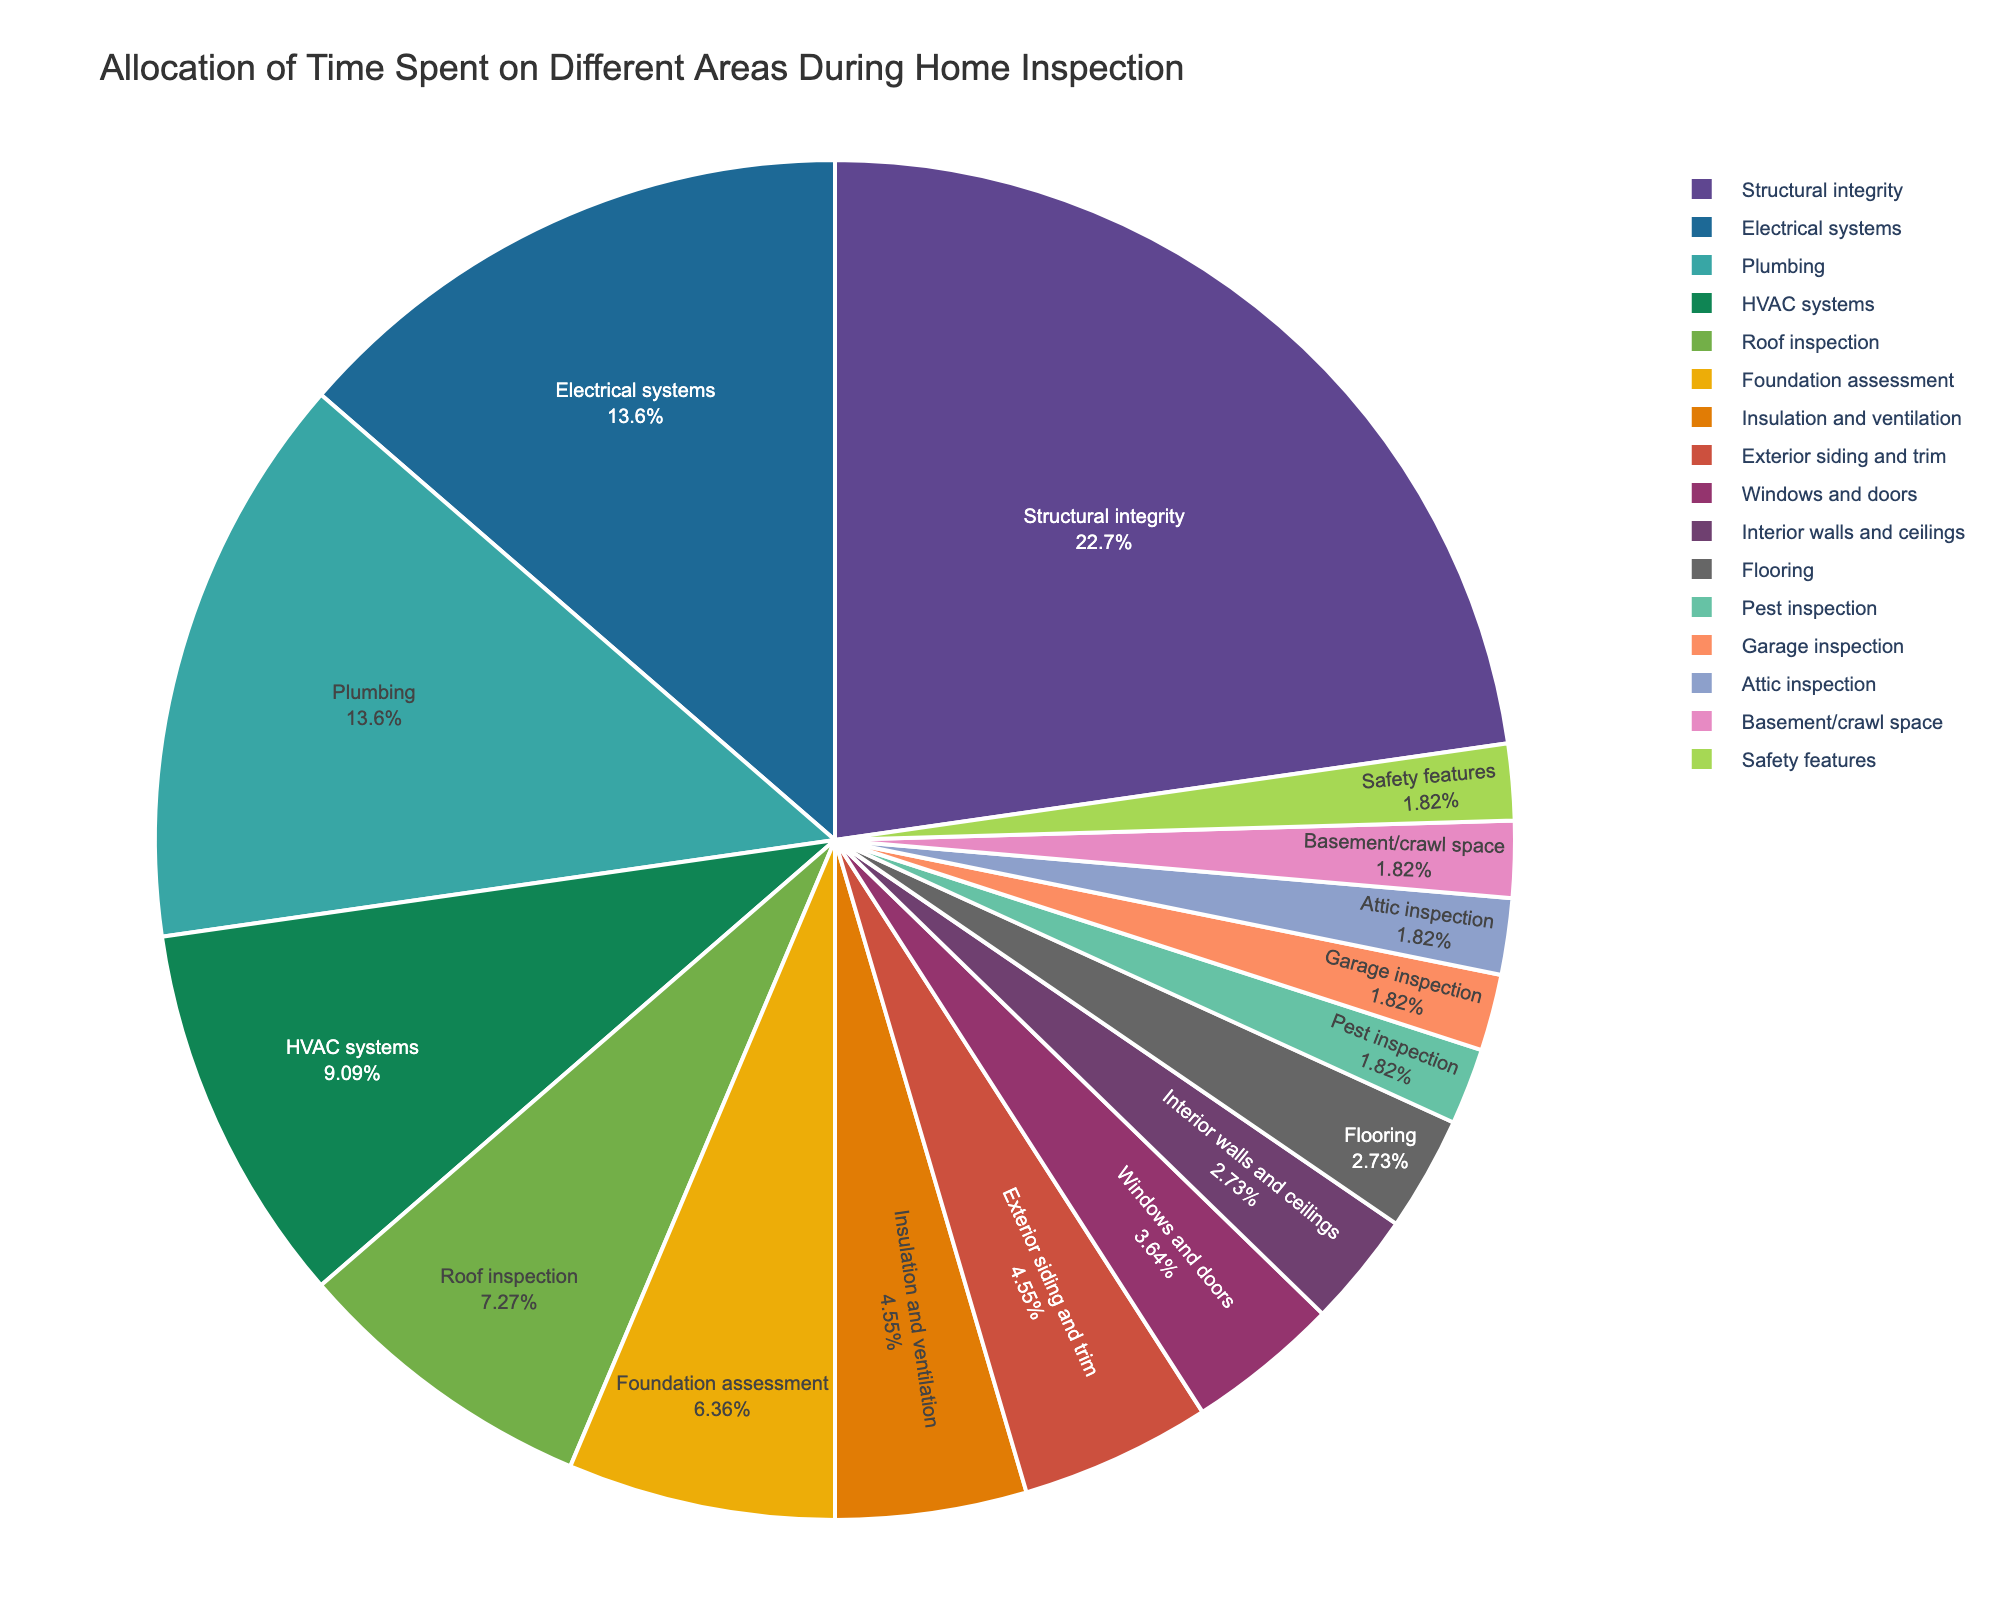What area is given the highest allocation of time during the home inspection? The pie chart shows the allocation of time, and the section labeled "Structural integrity" has the largest portion at 25%.
Answer: Structural integrity Which two areas receive the second-highest allocation of time and are they equal? The sections labeled "Electrical systems" and "Plumbing" each have the same percentage of time allocated at 15%.
Answer: Electrical systems and Plumbing, Yes How much more time is allocated to roof inspection compared to attic inspection? Roof inspection is allotted 8%, while attic inspection is given 2%. The difference is calculated as 8% - 2%.
Answer: 6% Which area receives less time than flooring but more time than basement/crawl space? From the chart, "Interior walls and ceilings" are at 3%, "Flooring" is also 3%, and "Basement/crawl space" is 2%. So, no area fits this criteria as 'flooring' and 'Interior walls and ceilings' have equal time
Answer: None What is the sum of the percentages allocated to Pest inspection, Garage inspection, Attic inspection, and Basement/crawl space? Summing up the percentages: Pest inspection (2%) + Garage inspection (2%) + Attic inspection (2%) + Basement/crawl space (2%) results in 2 + 2 + 2 + 2 = 8%.
Answer: 8% Are there any areas allocated less time than Safety features? Safety features are allocated 2%, and according to the chart, no areas are allocated less than or equal to this.
Answer: No Which areas of the home inspection receive an equal allocation of time? The chart shows that "Electrical systems" and "Plumbing" both receive 15%, "Flooring" and "Interior walls and ceilings" both receive 3%, "Pest inspection", "Garage inspection", "Attic inspection", "Basement/crawl space", and "Safety features" each receive 2%.
Answer: Electrical systems and Plumbing, Flooring and Interior walls and ceilings, Pest inspection, Garage inspection, Attic inspection, Basement/crawl space, Safety features Which area is allocated more time: Insulation and ventilation or Exterior siding and trim? Insulation and ventilation has 5% allocation, the same as Exterior siding and trim.
Answer: Equal If one needs to cut down 10% of the inspection time, which area should be reduced to achieve this given they reduce first from the largest segments? The largest segment is "Structural integrity" at 25%. Reducing 10% from this area will directly achieve the cut without affecting other areas.
Answer: Structural integrity Which are the top three most time-consuming areas of the inspection? According to the chart, the top three areas by time allocation are "Structural integrity" (25%), "Electrical systems" (15%), and "Plumbing" (15%).
Answer: Structural integrity, Electrical systems, Plumbing 